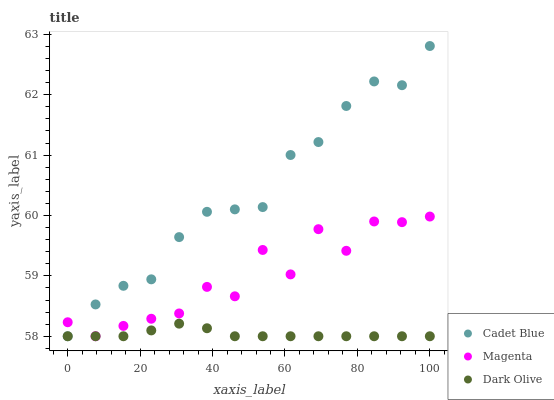Does Dark Olive have the minimum area under the curve?
Answer yes or no. Yes. Does Cadet Blue have the maximum area under the curve?
Answer yes or no. Yes. Does Magenta have the minimum area under the curve?
Answer yes or no. No. Does Magenta have the maximum area under the curve?
Answer yes or no. No. Is Dark Olive the smoothest?
Answer yes or no. Yes. Is Magenta the roughest?
Answer yes or no. Yes. Is Cadet Blue the smoothest?
Answer yes or no. No. Is Cadet Blue the roughest?
Answer yes or no. No. Does Dark Olive have the lowest value?
Answer yes or no. Yes. Does Cadet Blue have the highest value?
Answer yes or no. Yes. Does Magenta have the highest value?
Answer yes or no. No. Does Magenta intersect Dark Olive?
Answer yes or no. Yes. Is Magenta less than Dark Olive?
Answer yes or no. No. Is Magenta greater than Dark Olive?
Answer yes or no. No. 